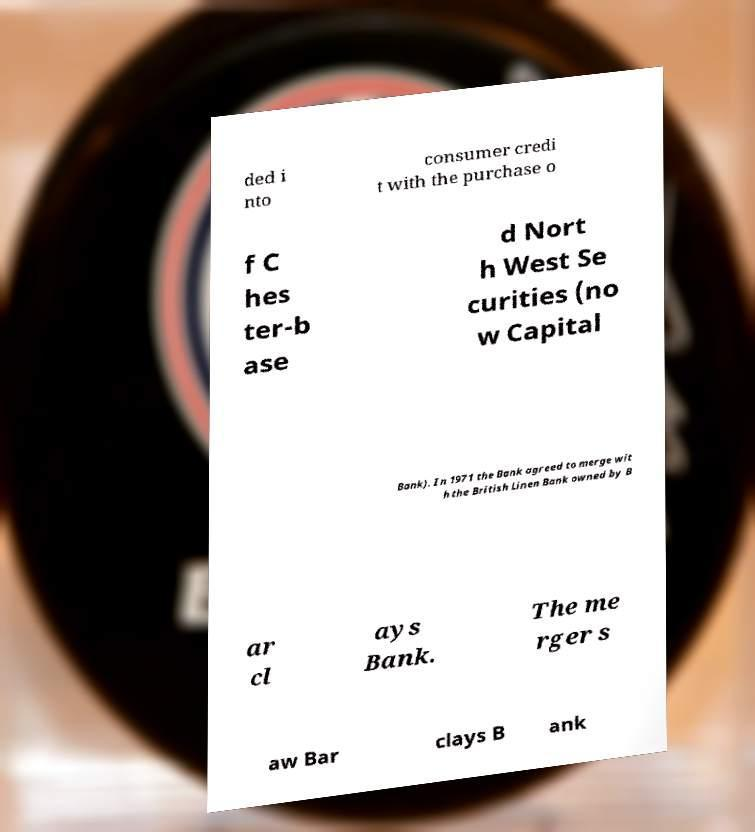Could you extract and type out the text from this image? ded i nto consumer credi t with the purchase o f C hes ter-b ase d Nort h West Se curities (no w Capital Bank). In 1971 the Bank agreed to merge wit h the British Linen Bank owned by B ar cl ays Bank. The me rger s aw Bar clays B ank 